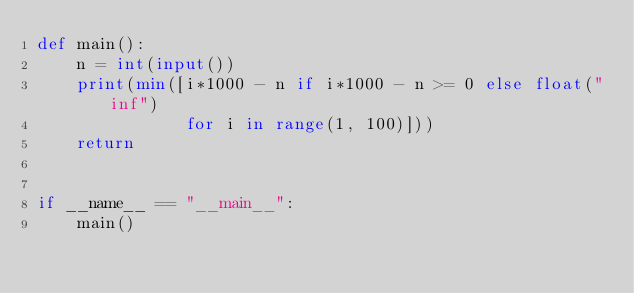Convert code to text. <code><loc_0><loc_0><loc_500><loc_500><_Python_>def main():
    n = int(input())
    print(min([i*1000 - n if i*1000 - n >= 0 else float("inf")
               for i in range(1, 100)]))
    return


if __name__ == "__main__":
    main()
</code> 